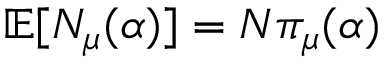<formula> <loc_0><loc_0><loc_500><loc_500>\mathbb { E } [ N _ { \mu } ( \alpha ) ] = N { \pi } _ { \mu } ( \alpha )</formula> 